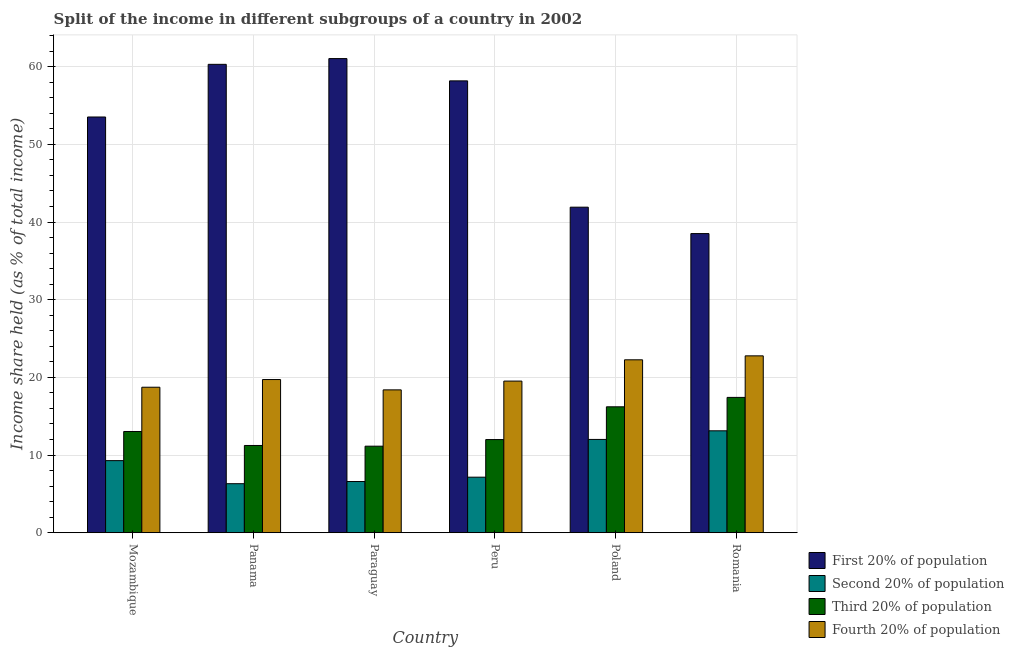How many different coloured bars are there?
Ensure brevity in your answer.  4. How many bars are there on the 3rd tick from the left?
Offer a terse response. 4. What is the label of the 3rd group of bars from the left?
Offer a terse response. Paraguay. What is the share of the income held by first 20% of the population in Panama?
Make the answer very short. 60.3. Across all countries, what is the maximum share of the income held by first 20% of the population?
Your answer should be compact. 61.04. Across all countries, what is the minimum share of the income held by fourth 20% of the population?
Your answer should be very brief. 18.39. In which country was the share of the income held by first 20% of the population maximum?
Your answer should be compact. Paraguay. In which country was the share of the income held by second 20% of the population minimum?
Your response must be concise. Panama. What is the total share of the income held by fourth 20% of the population in the graph?
Keep it short and to the point. 121.39. What is the difference between the share of the income held by first 20% of the population in Panama and that in Paraguay?
Your answer should be compact. -0.74. What is the difference between the share of the income held by first 20% of the population in Paraguay and the share of the income held by third 20% of the population in Peru?
Give a very brief answer. 49.05. What is the average share of the income held by second 20% of the population per country?
Keep it short and to the point. 9.08. What is the difference between the share of the income held by second 20% of the population and share of the income held by fourth 20% of the population in Panama?
Your answer should be very brief. -13.41. What is the ratio of the share of the income held by first 20% of the population in Mozambique to that in Romania?
Give a very brief answer. 1.39. Is the share of the income held by fourth 20% of the population in Peru less than that in Romania?
Ensure brevity in your answer.  Yes. What is the difference between the highest and the second highest share of the income held by first 20% of the population?
Your answer should be compact. 0.74. What is the difference between the highest and the lowest share of the income held by third 20% of the population?
Provide a short and direct response. 6.28. What does the 2nd bar from the left in Panama represents?
Offer a very short reply. Second 20% of population. What does the 3rd bar from the right in Romania represents?
Your response must be concise. Second 20% of population. Is it the case that in every country, the sum of the share of the income held by first 20% of the population and share of the income held by second 20% of the population is greater than the share of the income held by third 20% of the population?
Provide a succinct answer. Yes. How many bars are there?
Keep it short and to the point. 24. Are all the bars in the graph horizontal?
Ensure brevity in your answer.  No. How many countries are there in the graph?
Provide a short and direct response. 6. Where does the legend appear in the graph?
Keep it short and to the point. Bottom right. How many legend labels are there?
Keep it short and to the point. 4. How are the legend labels stacked?
Provide a short and direct response. Vertical. What is the title of the graph?
Ensure brevity in your answer.  Split of the income in different subgroups of a country in 2002. Does "Terrestrial protected areas" appear as one of the legend labels in the graph?
Your answer should be very brief. No. What is the label or title of the X-axis?
Provide a short and direct response. Country. What is the label or title of the Y-axis?
Offer a terse response. Income share held (as % of total income). What is the Income share held (as % of total income) in First 20% of population in Mozambique?
Your response must be concise. 53.52. What is the Income share held (as % of total income) in Second 20% of population in Mozambique?
Keep it short and to the point. 9.28. What is the Income share held (as % of total income) of Third 20% of population in Mozambique?
Offer a terse response. 13.03. What is the Income share held (as % of total income) in Fourth 20% of population in Mozambique?
Your answer should be compact. 18.73. What is the Income share held (as % of total income) in First 20% of population in Panama?
Give a very brief answer. 60.3. What is the Income share held (as % of total income) in Second 20% of population in Panama?
Keep it short and to the point. 6.31. What is the Income share held (as % of total income) of Third 20% of population in Panama?
Offer a terse response. 11.23. What is the Income share held (as % of total income) in Fourth 20% of population in Panama?
Ensure brevity in your answer.  19.72. What is the Income share held (as % of total income) of First 20% of population in Paraguay?
Your answer should be compact. 61.04. What is the Income share held (as % of total income) in Second 20% of population in Paraguay?
Ensure brevity in your answer.  6.59. What is the Income share held (as % of total income) in Third 20% of population in Paraguay?
Your answer should be very brief. 11.14. What is the Income share held (as % of total income) of Fourth 20% of population in Paraguay?
Make the answer very short. 18.39. What is the Income share held (as % of total income) of First 20% of population in Peru?
Your answer should be very brief. 58.17. What is the Income share held (as % of total income) of Second 20% of population in Peru?
Make the answer very short. 7.15. What is the Income share held (as % of total income) of Third 20% of population in Peru?
Offer a terse response. 11.99. What is the Income share held (as % of total income) in Fourth 20% of population in Peru?
Provide a succinct answer. 19.52. What is the Income share held (as % of total income) in First 20% of population in Poland?
Offer a very short reply. 41.91. What is the Income share held (as % of total income) of Second 20% of population in Poland?
Offer a terse response. 12.01. What is the Income share held (as % of total income) in Third 20% of population in Poland?
Offer a terse response. 16.21. What is the Income share held (as % of total income) in Fourth 20% of population in Poland?
Provide a short and direct response. 22.26. What is the Income share held (as % of total income) in First 20% of population in Romania?
Offer a very short reply. 38.51. What is the Income share held (as % of total income) of Second 20% of population in Romania?
Your answer should be very brief. 13.12. What is the Income share held (as % of total income) in Third 20% of population in Romania?
Your answer should be compact. 17.42. What is the Income share held (as % of total income) of Fourth 20% of population in Romania?
Offer a very short reply. 22.77. Across all countries, what is the maximum Income share held (as % of total income) in First 20% of population?
Make the answer very short. 61.04. Across all countries, what is the maximum Income share held (as % of total income) in Second 20% of population?
Your response must be concise. 13.12. Across all countries, what is the maximum Income share held (as % of total income) of Third 20% of population?
Your response must be concise. 17.42. Across all countries, what is the maximum Income share held (as % of total income) of Fourth 20% of population?
Offer a terse response. 22.77. Across all countries, what is the minimum Income share held (as % of total income) of First 20% of population?
Provide a succinct answer. 38.51. Across all countries, what is the minimum Income share held (as % of total income) in Second 20% of population?
Your answer should be compact. 6.31. Across all countries, what is the minimum Income share held (as % of total income) in Third 20% of population?
Your answer should be very brief. 11.14. Across all countries, what is the minimum Income share held (as % of total income) of Fourth 20% of population?
Offer a very short reply. 18.39. What is the total Income share held (as % of total income) of First 20% of population in the graph?
Offer a terse response. 313.45. What is the total Income share held (as % of total income) of Second 20% of population in the graph?
Your answer should be compact. 54.46. What is the total Income share held (as % of total income) in Third 20% of population in the graph?
Give a very brief answer. 81.02. What is the total Income share held (as % of total income) in Fourth 20% of population in the graph?
Keep it short and to the point. 121.39. What is the difference between the Income share held (as % of total income) of First 20% of population in Mozambique and that in Panama?
Provide a short and direct response. -6.78. What is the difference between the Income share held (as % of total income) in Second 20% of population in Mozambique and that in Panama?
Your answer should be very brief. 2.97. What is the difference between the Income share held (as % of total income) of Fourth 20% of population in Mozambique and that in Panama?
Ensure brevity in your answer.  -0.99. What is the difference between the Income share held (as % of total income) in First 20% of population in Mozambique and that in Paraguay?
Offer a very short reply. -7.52. What is the difference between the Income share held (as % of total income) of Second 20% of population in Mozambique and that in Paraguay?
Give a very brief answer. 2.69. What is the difference between the Income share held (as % of total income) of Third 20% of population in Mozambique and that in Paraguay?
Your response must be concise. 1.89. What is the difference between the Income share held (as % of total income) in Fourth 20% of population in Mozambique and that in Paraguay?
Provide a short and direct response. 0.34. What is the difference between the Income share held (as % of total income) in First 20% of population in Mozambique and that in Peru?
Your answer should be very brief. -4.65. What is the difference between the Income share held (as % of total income) of Second 20% of population in Mozambique and that in Peru?
Provide a short and direct response. 2.13. What is the difference between the Income share held (as % of total income) in Fourth 20% of population in Mozambique and that in Peru?
Your response must be concise. -0.79. What is the difference between the Income share held (as % of total income) of First 20% of population in Mozambique and that in Poland?
Ensure brevity in your answer.  11.61. What is the difference between the Income share held (as % of total income) in Second 20% of population in Mozambique and that in Poland?
Your answer should be very brief. -2.73. What is the difference between the Income share held (as % of total income) in Third 20% of population in Mozambique and that in Poland?
Your answer should be compact. -3.18. What is the difference between the Income share held (as % of total income) of Fourth 20% of population in Mozambique and that in Poland?
Provide a succinct answer. -3.53. What is the difference between the Income share held (as % of total income) in First 20% of population in Mozambique and that in Romania?
Offer a very short reply. 15.01. What is the difference between the Income share held (as % of total income) of Second 20% of population in Mozambique and that in Romania?
Your answer should be very brief. -3.84. What is the difference between the Income share held (as % of total income) of Third 20% of population in Mozambique and that in Romania?
Offer a terse response. -4.39. What is the difference between the Income share held (as % of total income) of Fourth 20% of population in Mozambique and that in Romania?
Provide a succinct answer. -4.04. What is the difference between the Income share held (as % of total income) in First 20% of population in Panama and that in Paraguay?
Make the answer very short. -0.74. What is the difference between the Income share held (as % of total income) in Second 20% of population in Panama and that in Paraguay?
Offer a very short reply. -0.28. What is the difference between the Income share held (as % of total income) of Third 20% of population in Panama and that in Paraguay?
Your response must be concise. 0.09. What is the difference between the Income share held (as % of total income) of Fourth 20% of population in Panama and that in Paraguay?
Make the answer very short. 1.33. What is the difference between the Income share held (as % of total income) of First 20% of population in Panama and that in Peru?
Your response must be concise. 2.13. What is the difference between the Income share held (as % of total income) in Second 20% of population in Panama and that in Peru?
Give a very brief answer. -0.84. What is the difference between the Income share held (as % of total income) in Third 20% of population in Panama and that in Peru?
Offer a very short reply. -0.76. What is the difference between the Income share held (as % of total income) of Fourth 20% of population in Panama and that in Peru?
Make the answer very short. 0.2. What is the difference between the Income share held (as % of total income) of First 20% of population in Panama and that in Poland?
Provide a succinct answer. 18.39. What is the difference between the Income share held (as % of total income) in Second 20% of population in Panama and that in Poland?
Your answer should be very brief. -5.7. What is the difference between the Income share held (as % of total income) in Third 20% of population in Panama and that in Poland?
Provide a succinct answer. -4.98. What is the difference between the Income share held (as % of total income) in Fourth 20% of population in Panama and that in Poland?
Offer a terse response. -2.54. What is the difference between the Income share held (as % of total income) in First 20% of population in Panama and that in Romania?
Make the answer very short. 21.79. What is the difference between the Income share held (as % of total income) of Second 20% of population in Panama and that in Romania?
Your answer should be compact. -6.81. What is the difference between the Income share held (as % of total income) in Third 20% of population in Panama and that in Romania?
Your response must be concise. -6.19. What is the difference between the Income share held (as % of total income) of Fourth 20% of population in Panama and that in Romania?
Keep it short and to the point. -3.05. What is the difference between the Income share held (as % of total income) of First 20% of population in Paraguay and that in Peru?
Offer a terse response. 2.87. What is the difference between the Income share held (as % of total income) of Second 20% of population in Paraguay and that in Peru?
Offer a very short reply. -0.56. What is the difference between the Income share held (as % of total income) of Third 20% of population in Paraguay and that in Peru?
Make the answer very short. -0.85. What is the difference between the Income share held (as % of total income) in Fourth 20% of population in Paraguay and that in Peru?
Keep it short and to the point. -1.13. What is the difference between the Income share held (as % of total income) of First 20% of population in Paraguay and that in Poland?
Offer a very short reply. 19.13. What is the difference between the Income share held (as % of total income) of Second 20% of population in Paraguay and that in Poland?
Provide a succinct answer. -5.42. What is the difference between the Income share held (as % of total income) of Third 20% of population in Paraguay and that in Poland?
Offer a very short reply. -5.07. What is the difference between the Income share held (as % of total income) in Fourth 20% of population in Paraguay and that in Poland?
Your answer should be very brief. -3.87. What is the difference between the Income share held (as % of total income) of First 20% of population in Paraguay and that in Romania?
Give a very brief answer. 22.53. What is the difference between the Income share held (as % of total income) in Second 20% of population in Paraguay and that in Romania?
Offer a very short reply. -6.53. What is the difference between the Income share held (as % of total income) of Third 20% of population in Paraguay and that in Romania?
Offer a very short reply. -6.28. What is the difference between the Income share held (as % of total income) of Fourth 20% of population in Paraguay and that in Romania?
Offer a very short reply. -4.38. What is the difference between the Income share held (as % of total income) of First 20% of population in Peru and that in Poland?
Ensure brevity in your answer.  16.26. What is the difference between the Income share held (as % of total income) of Second 20% of population in Peru and that in Poland?
Make the answer very short. -4.86. What is the difference between the Income share held (as % of total income) of Third 20% of population in Peru and that in Poland?
Offer a very short reply. -4.22. What is the difference between the Income share held (as % of total income) in Fourth 20% of population in Peru and that in Poland?
Keep it short and to the point. -2.74. What is the difference between the Income share held (as % of total income) of First 20% of population in Peru and that in Romania?
Make the answer very short. 19.66. What is the difference between the Income share held (as % of total income) of Second 20% of population in Peru and that in Romania?
Keep it short and to the point. -5.97. What is the difference between the Income share held (as % of total income) of Third 20% of population in Peru and that in Romania?
Give a very brief answer. -5.43. What is the difference between the Income share held (as % of total income) of Fourth 20% of population in Peru and that in Romania?
Give a very brief answer. -3.25. What is the difference between the Income share held (as % of total income) of First 20% of population in Poland and that in Romania?
Your answer should be very brief. 3.4. What is the difference between the Income share held (as % of total income) of Second 20% of population in Poland and that in Romania?
Keep it short and to the point. -1.11. What is the difference between the Income share held (as % of total income) in Third 20% of population in Poland and that in Romania?
Make the answer very short. -1.21. What is the difference between the Income share held (as % of total income) in Fourth 20% of population in Poland and that in Romania?
Keep it short and to the point. -0.51. What is the difference between the Income share held (as % of total income) of First 20% of population in Mozambique and the Income share held (as % of total income) of Second 20% of population in Panama?
Your answer should be very brief. 47.21. What is the difference between the Income share held (as % of total income) of First 20% of population in Mozambique and the Income share held (as % of total income) of Third 20% of population in Panama?
Offer a very short reply. 42.29. What is the difference between the Income share held (as % of total income) in First 20% of population in Mozambique and the Income share held (as % of total income) in Fourth 20% of population in Panama?
Your answer should be compact. 33.8. What is the difference between the Income share held (as % of total income) in Second 20% of population in Mozambique and the Income share held (as % of total income) in Third 20% of population in Panama?
Offer a very short reply. -1.95. What is the difference between the Income share held (as % of total income) in Second 20% of population in Mozambique and the Income share held (as % of total income) in Fourth 20% of population in Panama?
Keep it short and to the point. -10.44. What is the difference between the Income share held (as % of total income) of Third 20% of population in Mozambique and the Income share held (as % of total income) of Fourth 20% of population in Panama?
Offer a very short reply. -6.69. What is the difference between the Income share held (as % of total income) in First 20% of population in Mozambique and the Income share held (as % of total income) in Second 20% of population in Paraguay?
Make the answer very short. 46.93. What is the difference between the Income share held (as % of total income) in First 20% of population in Mozambique and the Income share held (as % of total income) in Third 20% of population in Paraguay?
Your answer should be very brief. 42.38. What is the difference between the Income share held (as % of total income) of First 20% of population in Mozambique and the Income share held (as % of total income) of Fourth 20% of population in Paraguay?
Make the answer very short. 35.13. What is the difference between the Income share held (as % of total income) in Second 20% of population in Mozambique and the Income share held (as % of total income) in Third 20% of population in Paraguay?
Give a very brief answer. -1.86. What is the difference between the Income share held (as % of total income) of Second 20% of population in Mozambique and the Income share held (as % of total income) of Fourth 20% of population in Paraguay?
Offer a very short reply. -9.11. What is the difference between the Income share held (as % of total income) of Third 20% of population in Mozambique and the Income share held (as % of total income) of Fourth 20% of population in Paraguay?
Provide a short and direct response. -5.36. What is the difference between the Income share held (as % of total income) of First 20% of population in Mozambique and the Income share held (as % of total income) of Second 20% of population in Peru?
Your response must be concise. 46.37. What is the difference between the Income share held (as % of total income) in First 20% of population in Mozambique and the Income share held (as % of total income) in Third 20% of population in Peru?
Give a very brief answer. 41.53. What is the difference between the Income share held (as % of total income) of Second 20% of population in Mozambique and the Income share held (as % of total income) of Third 20% of population in Peru?
Your answer should be compact. -2.71. What is the difference between the Income share held (as % of total income) of Second 20% of population in Mozambique and the Income share held (as % of total income) of Fourth 20% of population in Peru?
Provide a succinct answer. -10.24. What is the difference between the Income share held (as % of total income) of Third 20% of population in Mozambique and the Income share held (as % of total income) of Fourth 20% of population in Peru?
Make the answer very short. -6.49. What is the difference between the Income share held (as % of total income) of First 20% of population in Mozambique and the Income share held (as % of total income) of Second 20% of population in Poland?
Your answer should be compact. 41.51. What is the difference between the Income share held (as % of total income) in First 20% of population in Mozambique and the Income share held (as % of total income) in Third 20% of population in Poland?
Keep it short and to the point. 37.31. What is the difference between the Income share held (as % of total income) of First 20% of population in Mozambique and the Income share held (as % of total income) of Fourth 20% of population in Poland?
Offer a very short reply. 31.26. What is the difference between the Income share held (as % of total income) of Second 20% of population in Mozambique and the Income share held (as % of total income) of Third 20% of population in Poland?
Give a very brief answer. -6.93. What is the difference between the Income share held (as % of total income) of Second 20% of population in Mozambique and the Income share held (as % of total income) of Fourth 20% of population in Poland?
Make the answer very short. -12.98. What is the difference between the Income share held (as % of total income) in Third 20% of population in Mozambique and the Income share held (as % of total income) in Fourth 20% of population in Poland?
Ensure brevity in your answer.  -9.23. What is the difference between the Income share held (as % of total income) of First 20% of population in Mozambique and the Income share held (as % of total income) of Second 20% of population in Romania?
Provide a short and direct response. 40.4. What is the difference between the Income share held (as % of total income) in First 20% of population in Mozambique and the Income share held (as % of total income) in Third 20% of population in Romania?
Keep it short and to the point. 36.1. What is the difference between the Income share held (as % of total income) in First 20% of population in Mozambique and the Income share held (as % of total income) in Fourth 20% of population in Romania?
Ensure brevity in your answer.  30.75. What is the difference between the Income share held (as % of total income) of Second 20% of population in Mozambique and the Income share held (as % of total income) of Third 20% of population in Romania?
Offer a terse response. -8.14. What is the difference between the Income share held (as % of total income) of Second 20% of population in Mozambique and the Income share held (as % of total income) of Fourth 20% of population in Romania?
Your response must be concise. -13.49. What is the difference between the Income share held (as % of total income) in Third 20% of population in Mozambique and the Income share held (as % of total income) in Fourth 20% of population in Romania?
Offer a terse response. -9.74. What is the difference between the Income share held (as % of total income) of First 20% of population in Panama and the Income share held (as % of total income) of Second 20% of population in Paraguay?
Make the answer very short. 53.71. What is the difference between the Income share held (as % of total income) of First 20% of population in Panama and the Income share held (as % of total income) of Third 20% of population in Paraguay?
Offer a very short reply. 49.16. What is the difference between the Income share held (as % of total income) of First 20% of population in Panama and the Income share held (as % of total income) of Fourth 20% of population in Paraguay?
Keep it short and to the point. 41.91. What is the difference between the Income share held (as % of total income) of Second 20% of population in Panama and the Income share held (as % of total income) of Third 20% of population in Paraguay?
Your answer should be compact. -4.83. What is the difference between the Income share held (as % of total income) in Second 20% of population in Panama and the Income share held (as % of total income) in Fourth 20% of population in Paraguay?
Provide a succinct answer. -12.08. What is the difference between the Income share held (as % of total income) in Third 20% of population in Panama and the Income share held (as % of total income) in Fourth 20% of population in Paraguay?
Keep it short and to the point. -7.16. What is the difference between the Income share held (as % of total income) in First 20% of population in Panama and the Income share held (as % of total income) in Second 20% of population in Peru?
Your answer should be very brief. 53.15. What is the difference between the Income share held (as % of total income) in First 20% of population in Panama and the Income share held (as % of total income) in Third 20% of population in Peru?
Offer a terse response. 48.31. What is the difference between the Income share held (as % of total income) in First 20% of population in Panama and the Income share held (as % of total income) in Fourth 20% of population in Peru?
Ensure brevity in your answer.  40.78. What is the difference between the Income share held (as % of total income) of Second 20% of population in Panama and the Income share held (as % of total income) of Third 20% of population in Peru?
Ensure brevity in your answer.  -5.68. What is the difference between the Income share held (as % of total income) of Second 20% of population in Panama and the Income share held (as % of total income) of Fourth 20% of population in Peru?
Provide a succinct answer. -13.21. What is the difference between the Income share held (as % of total income) of Third 20% of population in Panama and the Income share held (as % of total income) of Fourth 20% of population in Peru?
Ensure brevity in your answer.  -8.29. What is the difference between the Income share held (as % of total income) of First 20% of population in Panama and the Income share held (as % of total income) of Second 20% of population in Poland?
Offer a very short reply. 48.29. What is the difference between the Income share held (as % of total income) in First 20% of population in Panama and the Income share held (as % of total income) in Third 20% of population in Poland?
Give a very brief answer. 44.09. What is the difference between the Income share held (as % of total income) in First 20% of population in Panama and the Income share held (as % of total income) in Fourth 20% of population in Poland?
Your answer should be compact. 38.04. What is the difference between the Income share held (as % of total income) in Second 20% of population in Panama and the Income share held (as % of total income) in Fourth 20% of population in Poland?
Make the answer very short. -15.95. What is the difference between the Income share held (as % of total income) in Third 20% of population in Panama and the Income share held (as % of total income) in Fourth 20% of population in Poland?
Offer a terse response. -11.03. What is the difference between the Income share held (as % of total income) of First 20% of population in Panama and the Income share held (as % of total income) of Second 20% of population in Romania?
Give a very brief answer. 47.18. What is the difference between the Income share held (as % of total income) of First 20% of population in Panama and the Income share held (as % of total income) of Third 20% of population in Romania?
Give a very brief answer. 42.88. What is the difference between the Income share held (as % of total income) in First 20% of population in Panama and the Income share held (as % of total income) in Fourth 20% of population in Romania?
Make the answer very short. 37.53. What is the difference between the Income share held (as % of total income) in Second 20% of population in Panama and the Income share held (as % of total income) in Third 20% of population in Romania?
Your answer should be compact. -11.11. What is the difference between the Income share held (as % of total income) in Second 20% of population in Panama and the Income share held (as % of total income) in Fourth 20% of population in Romania?
Provide a succinct answer. -16.46. What is the difference between the Income share held (as % of total income) in Third 20% of population in Panama and the Income share held (as % of total income) in Fourth 20% of population in Romania?
Offer a very short reply. -11.54. What is the difference between the Income share held (as % of total income) of First 20% of population in Paraguay and the Income share held (as % of total income) of Second 20% of population in Peru?
Ensure brevity in your answer.  53.89. What is the difference between the Income share held (as % of total income) in First 20% of population in Paraguay and the Income share held (as % of total income) in Third 20% of population in Peru?
Your response must be concise. 49.05. What is the difference between the Income share held (as % of total income) of First 20% of population in Paraguay and the Income share held (as % of total income) of Fourth 20% of population in Peru?
Your answer should be compact. 41.52. What is the difference between the Income share held (as % of total income) in Second 20% of population in Paraguay and the Income share held (as % of total income) in Fourth 20% of population in Peru?
Your response must be concise. -12.93. What is the difference between the Income share held (as % of total income) of Third 20% of population in Paraguay and the Income share held (as % of total income) of Fourth 20% of population in Peru?
Your answer should be compact. -8.38. What is the difference between the Income share held (as % of total income) of First 20% of population in Paraguay and the Income share held (as % of total income) of Second 20% of population in Poland?
Give a very brief answer. 49.03. What is the difference between the Income share held (as % of total income) in First 20% of population in Paraguay and the Income share held (as % of total income) in Third 20% of population in Poland?
Your response must be concise. 44.83. What is the difference between the Income share held (as % of total income) of First 20% of population in Paraguay and the Income share held (as % of total income) of Fourth 20% of population in Poland?
Provide a succinct answer. 38.78. What is the difference between the Income share held (as % of total income) in Second 20% of population in Paraguay and the Income share held (as % of total income) in Third 20% of population in Poland?
Ensure brevity in your answer.  -9.62. What is the difference between the Income share held (as % of total income) of Second 20% of population in Paraguay and the Income share held (as % of total income) of Fourth 20% of population in Poland?
Offer a terse response. -15.67. What is the difference between the Income share held (as % of total income) of Third 20% of population in Paraguay and the Income share held (as % of total income) of Fourth 20% of population in Poland?
Your answer should be very brief. -11.12. What is the difference between the Income share held (as % of total income) in First 20% of population in Paraguay and the Income share held (as % of total income) in Second 20% of population in Romania?
Give a very brief answer. 47.92. What is the difference between the Income share held (as % of total income) in First 20% of population in Paraguay and the Income share held (as % of total income) in Third 20% of population in Romania?
Your answer should be compact. 43.62. What is the difference between the Income share held (as % of total income) in First 20% of population in Paraguay and the Income share held (as % of total income) in Fourth 20% of population in Romania?
Provide a short and direct response. 38.27. What is the difference between the Income share held (as % of total income) of Second 20% of population in Paraguay and the Income share held (as % of total income) of Third 20% of population in Romania?
Your answer should be compact. -10.83. What is the difference between the Income share held (as % of total income) of Second 20% of population in Paraguay and the Income share held (as % of total income) of Fourth 20% of population in Romania?
Offer a very short reply. -16.18. What is the difference between the Income share held (as % of total income) in Third 20% of population in Paraguay and the Income share held (as % of total income) in Fourth 20% of population in Romania?
Your response must be concise. -11.63. What is the difference between the Income share held (as % of total income) in First 20% of population in Peru and the Income share held (as % of total income) in Second 20% of population in Poland?
Your response must be concise. 46.16. What is the difference between the Income share held (as % of total income) in First 20% of population in Peru and the Income share held (as % of total income) in Third 20% of population in Poland?
Your answer should be compact. 41.96. What is the difference between the Income share held (as % of total income) in First 20% of population in Peru and the Income share held (as % of total income) in Fourth 20% of population in Poland?
Offer a terse response. 35.91. What is the difference between the Income share held (as % of total income) in Second 20% of population in Peru and the Income share held (as % of total income) in Third 20% of population in Poland?
Make the answer very short. -9.06. What is the difference between the Income share held (as % of total income) in Second 20% of population in Peru and the Income share held (as % of total income) in Fourth 20% of population in Poland?
Offer a very short reply. -15.11. What is the difference between the Income share held (as % of total income) in Third 20% of population in Peru and the Income share held (as % of total income) in Fourth 20% of population in Poland?
Provide a succinct answer. -10.27. What is the difference between the Income share held (as % of total income) in First 20% of population in Peru and the Income share held (as % of total income) in Second 20% of population in Romania?
Your answer should be compact. 45.05. What is the difference between the Income share held (as % of total income) in First 20% of population in Peru and the Income share held (as % of total income) in Third 20% of population in Romania?
Offer a very short reply. 40.75. What is the difference between the Income share held (as % of total income) in First 20% of population in Peru and the Income share held (as % of total income) in Fourth 20% of population in Romania?
Give a very brief answer. 35.4. What is the difference between the Income share held (as % of total income) in Second 20% of population in Peru and the Income share held (as % of total income) in Third 20% of population in Romania?
Ensure brevity in your answer.  -10.27. What is the difference between the Income share held (as % of total income) in Second 20% of population in Peru and the Income share held (as % of total income) in Fourth 20% of population in Romania?
Offer a very short reply. -15.62. What is the difference between the Income share held (as % of total income) in Third 20% of population in Peru and the Income share held (as % of total income) in Fourth 20% of population in Romania?
Your answer should be compact. -10.78. What is the difference between the Income share held (as % of total income) of First 20% of population in Poland and the Income share held (as % of total income) of Second 20% of population in Romania?
Provide a succinct answer. 28.79. What is the difference between the Income share held (as % of total income) of First 20% of population in Poland and the Income share held (as % of total income) of Third 20% of population in Romania?
Make the answer very short. 24.49. What is the difference between the Income share held (as % of total income) in First 20% of population in Poland and the Income share held (as % of total income) in Fourth 20% of population in Romania?
Make the answer very short. 19.14. What is the difference between the Income share held (as % of total income) in Second 20% of population in Poland and the Income share held (as % of total income) in Third 20% of population in Romania?
Offer a terse response. -5.41. What is the difference between the Income share held (as % of total income) of Second 20% of population in Poland and the Income share held (as % of total income) of Fourth 20% of population in Romania?
Keep it short and to the point. -10.76. What is the difference between the Income share held (as % of total income) in Third 20% of population in Poland and the Income share held (as % of total income) in Fourth 20% of population in Romania?
Provide a short and direct response. -6.56. What is the average Income share held (as % of total income) in First 20% of population per country?
Make the answer very short. 52.24. What is the average Income share held (as % of total income) of Second 20% of population per country?
Make the answer very short. 9.08. What is the average Income share held (as % of total income) of Third 20% of population per country?
Provide a succinct answer. 13.5. What is the average Income share held (as % of total income) in Fourth 20% of population per country?
Give a very brief answer. 20.23. What is the difference between the Income share held (as % of total income) in First 20% of population and Income share held (as % of total income) in Second 20% of population in Mozambique?
Ensure brevity in your answer.  44.24. What is the difference between the Income share held (as % of total income) of First 20% of population and Income share held (as % of total income) of Third 20% of population in Mozambique?
Ensure brevity in your answer.  40.49. What is the difference between the Income share held (as % of total income) of First 20% of population and Income share held (as % of total income) of Fourth 20% of population in Mozambique?
Offer a terse response. 34.79. What is the difference between the Income share held (as % of total income) in Second 20% of population and Income share held (as % of total income) in Third 20% of population in Mozambique?
Your answer should be compact. -3.75. What is the difference between the Income share held (as % of total income) in Second 20% of population and Income share held (as % of total income) in Fourth 20% of population in Mozambique?
Your answer should be very brief. -9.45. What is the difference between the Income share held (as % of total income) of Third 20% of population and Income share held (as % of total income) of Fourth 20% of population in Mozambique?
Provide a succinct answer. -5.7. What is the difference between the Income share held (as % of total income) in First 20% of population and Income share held (as % of total income) in Second 20% of population in Panama?
Your answer should be very brief. 53.99. What is the difference between the Income share held (as % of total income) in First 20% of population and Income share held (as % of total income) in Third 20% of population in Panama?
Offer a terse response. 49.07. What is the difference between the Income share held (as % of total income) of First 20% of population and Income share held (as % of total income) of Fourth 20% of population in Panama?
Provide a succinct answer. 40.58. What is the difference between the Income share held (as % of total income) in Second 20% of population and Income share held (as % of total income) in Third 20% of population in Panama?
Ensure brevity in your answer.  -4.92. What is the difference between the Income share held (as % of total income) of Second 20% of population and Income share held (as % of total income) of Fourth 20% of population in Panama?
Your answer should be very brief. -13.41. What is the difference between the Income share held (as % of total income) in Third 20% of population and Income share held (as % of total income) in Fourth 20% of population in Panama?
Offer a very short reply. -8.49. What is the difference between the Income share held (as % of total income) in First 20% of population and Income share held (as % of total income) in Second 20% of population in Paraguay?
Provide a succinct answer. 54.45. What is the difference between the Income share held (as % of total income) in First 20% of population and Income share held (as % of total income) in Third 20% of population in Paraguay?
Offer a terse response. 49.9. What is the difference between the Income share held (as % of total income) of First 20% of population and Income share held (as % of total income) of Fourth 20% of population in Paraguay?
Keep it short and to the point. 42.65. What is the difference between the Income share held (as % of total income) in Second 20% of population and Income share held (as % of total income) in Third 20% of population in Paraguay?
Your answer should be compact. -4.55. What is the difference between the Income share held (as % of total income) in Second 20% of population and Income share held (as % of total income) in Fourth 20% of population in Paraguay?
Offer a terse response. -11.8. What is the difference between the Income share held (as % of total income) of Third 20% of population and Income share held (as % of total income) of Fourth 20% of population in Paraguay?
Give a very brief answer. -7.25. What is the difference between the Income share held (as % of total income) of First 20% of population and Income share held (as % of total income) of Second 20% of population in Peru?
Keep it short and to the point. 51.02. What is the difference between the Income share held (as % of total income) of First 20% of population and Income share held (as % of total income) of Third 20% of population in Peru?
Your answer should be very brief. 46.18. What is the difference between the Income share held (as % of total income) of First 20% of population and Income share held (as % of total income) of Fourth 20% of population in Peru?
Give a very brief answer. 38.65. What is the difference between the Income share held (as % of total income) in Second 20% of population and Income share held (as % of total income) in Third 20% of population in Peru?
Make the answer very short. -4.84. What is the difference between the Income share held (as % of total income) in Second 20% of population and Income share held (as % of total income) in Fourth 20% of population in Peru?
Give a very brief answer. -12.37. What is the difference between the Income share held (as % of total income) of Third 20% of population and Income share held (as % of total income) of Fourth 20% of population in Peru?
Make the answer very short. -7.53. What is the difference between the Income share held (as % of total income) in First 20% of population and Income share held (as % of total income) in Second 20% of population in Poland?
Give a very brief answer. 29.9. What is the difference between the Income share held (as % of total income) of First 20% of population and Income share held (as % of total income) of Third 20% of population in Poland?
Your answer should be very brief. 25.7. What is the difference between the Income share held (as % of total income) of First 20% of population and Income share held (as % of total income) of Fourth 20% of population in Poland?
Keep it short and to the point. 19.65. What is the difference between the Income share held (as % of total income) in Second 20% of population and Income share held (as % of total income) in Fourth 20% of population in Poland?
Provide a succinct answer. -10.25. What is the difference between the Income share held (as % of total income) of Third 20% of population and Income share held (as % of total income) of Fourth 20% of population in Poland?
Make the answer very short. -6.05. What is the difference between the Income share held (as % of total income) of First 20% of population and Income share held (as % of total income) of Second 20% of population in Romania?
Give a very brief answer. 25.39. What is the difference between the Income share held (as % of total income) in First 20% of population and Income share held (as % of total income) in Third 20% of population in Romania?
Your answer should be very brief. 21.09. What is the difference between the Income share held (as % of total income) in First 20% of population and Income share held (as % of total income) in Fourth 20% of population in Romania?
Your answer should be very brief. 15.74. What is the difference between the Income share held (as % of total income) of Second 20% of population and Income share held (as % of total income) of Fourth 20% of population in Romania?
Your response must be concise. -9.65. What is the difference between the Income share held (as % of total income) in Third 20% of population and Income share held (as % of total income) in Fourth 20% of population in Romania?
Your answer should be very brief. -5.35. What is the ratio of the Income share held (as % of total income) of First 20% of population in Mozambique to that in Panama?
Keep it short and to the point. 0.89. What is the ratio of the Income share held (as % of total income) of Second 20% of population in Mozambique to that in Panama?
Make the answer very short. 1.47. What is the ratio of the Income share held (as % of total income) of Third 20% of population in Mozambique to that in Panama?
Offer a very short reply. 1.16. What is the ratio of the Income share held (as % of total income) in Fourth 20% of population in Mozambique to that in Panama?
Your answer should be compact. 0.95. What is the ratio of the Income share held (as % of total income) in First 20% of population in Mozambique to that in Paraguay?
Keep it short and to the point. 0.88. What is the ratio of the Income share held (as % of total income) of Second 20% of population in Mozambique to that in Paraguay?
Provide a succinct answer. 1.41. What is the ratio of the Income share held (as % of total income) of Third 20% of population in Mozambique to that in Paraguay?
Your answer should be very brief. 1.17. What is the ratio of the Income share held (as % of total income) of Fourth 20% of population in Mozambique to that in Paraguay?
Make the answer very short. 1.02. What is the ratio of the Income share held (as % of total income) in First 20% of population in Mozambique to that in Peru?
Give a very brief answer. 0.92. What is the ratio of the Income share held (as % of total income) of Second 20% of population in Mozambique to that in Peru?
Your answer should be very brief. 1.3. What is the ratio of the Income share held (as % of total income) of Third 20% of population in Mozambique to that in Peru?
Your answer should be compact. 1.09. What is the ratio of the Income share held (as % of total income) in Fourth 20% of population in Mozambique to that in Peru?
Your answer should be compact. 0.96. What is the ratio of the Income share held (as % of total income) in First 20% of population in Mozambique to that in Poland?
Your answer should be compact. 1.28. What is the ratio of the Income share held (as % of total income) in Second 20% of population in Mozambique to that in Poland?
Keep it short and to the point. 0.77. What is the ratio of the Income share held (as % of total income) in Third 20% of population in Mozambique to that in Poland?
Give a very brief answer. 0.8. What is the ratio of the Income share held (as % of total income) in Fourth 20% of population in Mozambique to that in Poland?
Your answer should be compact. 0.84. What is the ratio of the Income share held (as % of total income) of First 20% of population in Mozambique to that in Romania?
Provide a succinct answer. 1.39. What is the ratio of the Income share held (as % of total income) in Second 20% of population in Mozambique to that in Romania?
Your response must be concise. 0.71. What is the ratio of the Income share held (as % of total income) in Third 20% of population in Mozambique to that in Romania?
Give a very brief answer. 0.75. What is the ratio of the Income share held (as % of total income) of Fourth 20% of population in Mozambique to that in Romania?
Keep it short and to the point. 0.82. What is the ratio of the Income share held (as % of total income) of First 20% of population in Panama to that in Paraguay?
Offer a very short reply. 0.99. What is the ratio of the Income share held (as % of total income) of Second 20% of population in Panama to that in Paraguay?
Your answer should be compact. 0.96. What is the ratio of the Income share held (as % of total income) in Third 20% of population in Panama to that in Paraguay?
Your answer should be very brief. 1.01. What is the ratio of the Income share held (as % of total income) in Fourth 20% of population in Panama to that in Paraguay?
Offer a terse response. 1.07. What is the ratio of the Income share held (as % of total income) in First 20% of population in Panama to that in Peru?
Keep it short and to the point. 1.04. What is the ratio of the Income share held (as % of total income) of Second 20% of population in Panama to that in Peru?
Provide a succinct answer. 0.88. What is the ratio of the Income share held (as % of total income) of Third 20% of population in Panama to that in Peru?
Ensure brevity in your answer.  0.94. What is the ratio of the Income share held (as % of total income) in Fourth 20% of population in Panama to that in Peru?
Ensure brevity in your answer.  1.01. What is the ratio of the Income share held (as % of total income) in First 20% of population in Panama to that in Poland?
Provide a succinct answer. 1.44. What is the ratio of the Income share held (as % of total income) of Second 20% of population in Panama to that in Poland?
Your answer should be compact. 0.53. What is the ratio of the Income share held (as % of total income) in Third 20% of population in Panama to that in Poland?
Ensure brevity in your answer.  0.69. What is the ratio of the Income share held (as % of total income) of Fourth 20% of population in Panama to that in Poland?
Your answer should be very brief. 0.89. What is the ratio of the Income share held (as % of total income) of First 20% of population in Panama to that in Romania?
Provide a succinct answer. 1.57. What is the ratio of the Income share held (as % of total income) of Second 20% of population in Panama to that in Romania?
Ensure brevity in your answer.  0.48. What is the ratio of the Income share held (as % of total income) in Third 20% of population in Panama to that in Romania?
Offer a very short reply. 0.64. What is the ratio of the Income share held (as % of total income) in Fourth 20% of population in Panama to that in Romania?
Offer a very short reply. 0.87. What is the ratio of the Income share held (as % of total income) of First 20% of population in Paraguay to that in Peru?
Offer a terse response. 1.05. What is the ratio of the Income share held (as % of total income) in Second 20% of population in Paraguay to that in Peru?
Your response must be concise. 0.92. What is the ratio of the Income share held (as % of total income) of Third 20% of population in Paraguay to that in Peru?
Give a very brief answer. 0.93. What is the ratio of the Income share held (as % of total income) in Fourth 20% of population in Paraguay to that in Peru?
Ensure brevity in your answer.  0.94. What is the ratio of the Income share held (as % of total income) of First 20% of population in Paraguay to that in Poland?
Your answer should be very brief. 1.46. What is the ratio of the Income share held (as % of total income) in Second 20% of population in Paraguay to that in Poland?
Your answer should be very brief. 0.55. What is the ratio of the Income share held (as % of total income) in Third 20% of population in Paraguay to that in Poland?
Give a very brief answer. 0.69. What is the ratio of the Income share held (as % of total income) in Fourth 20% of population in Paraguay to that in Poland?
Give a very brief answer. 0.83. What is the ratio of the Income share held (as % of total income) of First 20% of population in Paraguay to that in Romania?
Ensure brevity in your answer.  1.58. What is the ratio of the Income share held (as % of total income) of Second 20% of population in Paraguay to that in Romania?
Ensure brevity in your answer.  0.5. What is the ratio of the Income share held (as % of total income) in Third 20% of population in Paraguay to that in Romania?
Make the answer very short. 0.64. What is the ratio of the Income share held (as % of total income) in Fourth 20% of population in Paraguay to that in Romania?
Give a very brief answer. 0.81. What is the ratio of the Income share held (as % of total income) of First 20% of population in Peru to that in Poland?
Your answer should be very brief. 1.39. What is the ratio of the Income share held (as % of total income) in Second 20% of population in Peru to that in Poland?
Your answer should be compact. 0.6. What is the ratio of the Income share held (as % of total income) in Third 20% of population in Peru to that in Poland?
Ensure brevity in your answer.  0.74. What is the ratio of the Income share held (as % of total income) of Fourth 20% of population in Peru to that in Poland?
Provide a short and direct response. 0.88. What is the ratio of the Income share held (as % of total income) in First 20% of population in Peru to that in Romania?
Your answer should be compact. 1.51. What is the ratio of the Income share held (as % of total income) of Second 20% of population in Peru to that in Romania?
Provide a succinct answer. 0.55. What is the ratio of the Income share held (as % of total income) of Third 20% of population in Peru to that in Romania?
Your response must be concise. 0.69. What is the ratio of the Income share held (as % of total income) in Fourth 20% of population in Peru to that in Romania?
Ensure brevity in your answer.  0.86. What is the ratio of the Income share held (as % of total income) in First 20% of population in Poland to that in Romania?
Make the answer very short. 1.09. What is the ratio of the Income share held (as % of total income) in Second 20% of population in Poland to that in Romania?
Offer a terse response. 0.92. What is the ratio of the Income share held (as % of total income) of Third 20% of population in Poland to that in Romania?
Provide a short and direct response. 0.93. What is the ratio of the Income share held (as % of total income) of Fourth 20% of population in Poland to that in Romania?
Offer a terse response. 0.98. What is the difference between the highest and the second highest Income share held (as % of total income) of First 20% of population?
Offer a very short reply. 0.74. What is the difference between the highest and the second highest Income share held (as % of total income) of Second 20% of population?
Offer a terse response. 1.11. What is the difference between the highest and the second highest Income share held (as % of total income) in Third 20% of population?
Ensure brevity in your answer.  1.21. What is the difference between the highest and the second highest Income share held (as % of total income) of Fourth 20% of population?
Offer a terse response. 0.51. What is the difference between the highest and the lowest Income share held (as % of total income) of First 20% of population?
Make the answer very short. 22.53. What is the difference between the highest and the lowest Income share held (as % of total income) in Second 20% of population?
Offer a terse response. 6.81. What is the difference between the highest and the lowest Income share held (as % of total income) of Third 20% of population?
Your answer should be compact. 6.28. What is the difference between the highest and the lowest Income share held (as % of total income) in Fourth 20% of population?
Your response must be concise. 4.38. 